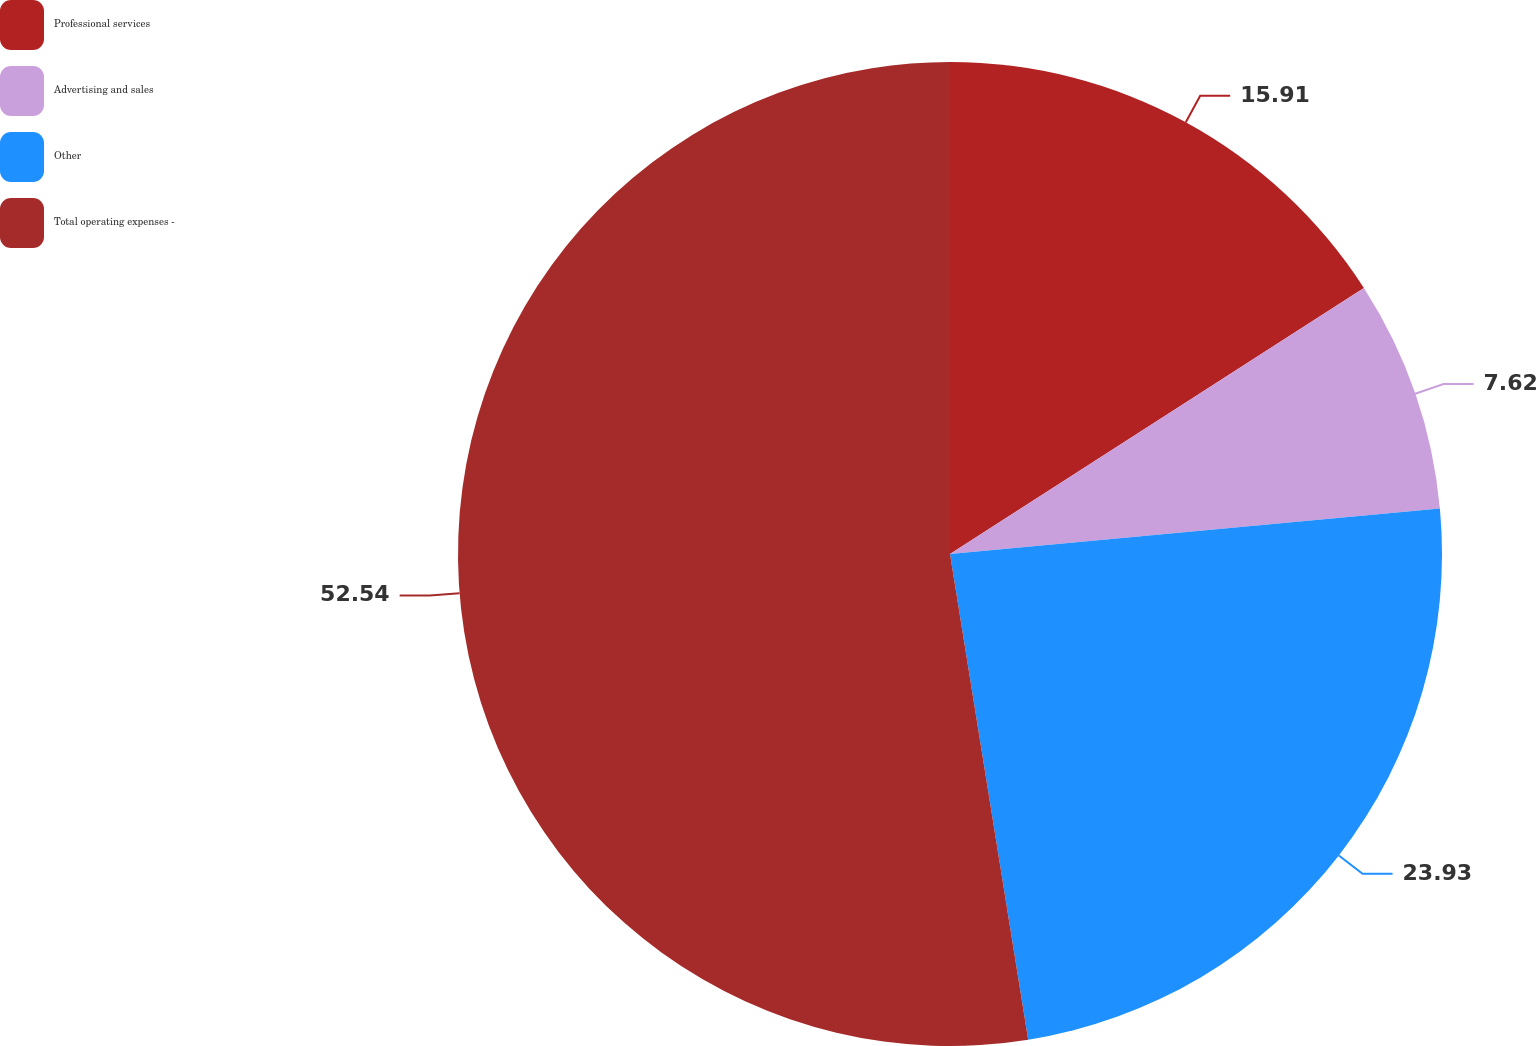Convert chart. <chart><loc_0><loc_0><loc_500><loc_500><pie_chart><fcel>Professional services<fcel>Advertising and sales<fcel>Other<fcel>Total operating expenses -<nl><fcel>15.91%<fcel>7.62%<fcel>23.93%<fcel>52.54%<nl></chart> 